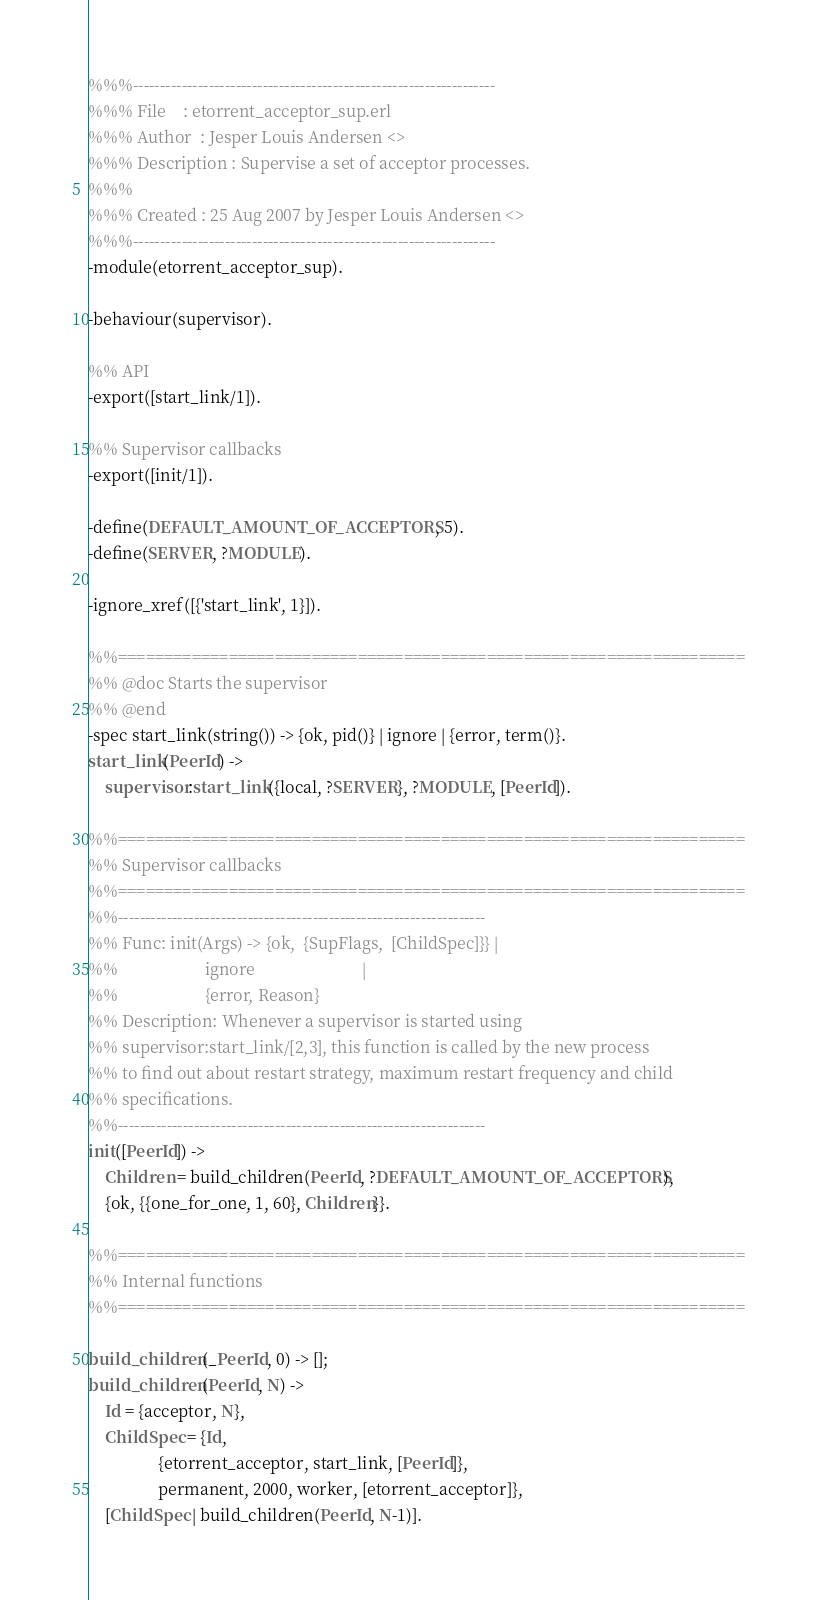<code> <loc_0><loc_0><loc_500><loc_500><_Erlang_>%%%-------------------------------------------------------------------
%%% File    : etorrent_acceptor_sup.erl
%%% Author  : Jesper Louis Andersen <>
%%% Description : Supervise a set of acceptor processes.
%%%
%%% Created : 25 Aug 2007 by Jesper Louis Andersen <>
%%%-------------------------------------------------------------------
-module(etorrent_acceptor_sup).

-behaviour(supervisor).

%% API
-export([start_link/1]).

%% Supervisor callbacks
-export([init/1]).

-define(DEFAULT_AMOUNT_OF_ACCEPTORS, 5).
-define(SERVER, ?MODULE).

-ignore_xref([{'start_link', 1}]).

%%====================================================================
%% @doc Starts the supervisor
%% @end
-spec start_link(string()) -> {ok, pid()} | ignore | {error, term()}.
start_link(PeerId) ->
    supervisor:start_link({local, ?SERVER}, ?MODULE, [PeerId]).

%%====================================================================
%% Supervisor callbacks
%%====================================================================
%%--------------------------------------------------------------------
%% Func: init(Args) -> {ok,  {SupFlags,  [ChildSpec]}} |
%%                     ignore                          |
%%                     {error, Reason}
%% Description: Whenever a supervisor is started using
%% supervisor:start_link/[2,3], this function is called by the new process
%% to find out about restart strategy, maximum restart frequency and child
%% specifications.
%%--------------------------------------------------------------------
init([PeerId]) ->
    Children = build_children(PeerId, ?DEFAULT_AMOUNT_OF_ACCEPTORS),
    {ok, {{one_for_one, 1, 60}, Children}}.

%%====================================================================
%% Internal functions
%%====================================================================

build_children(_PeerId, 0) -> [];
build_children(PeerId, N) ->
    Id = {acceptor, N},
    ChildSpec = {Id,
                 {etorrent_acceptor, start_link, [PeerId]},
                 permanent, 2000, worker, [etorrent_acceptor]},
    [ChildSpec | build_children(PeerId, N-1)].
</code> 